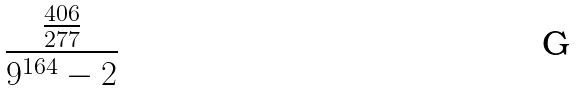<formula> <loc_0><loc_0><loc_500><loc_500>\frac { \frac { 4 0 6 } { 2 7 7 } } { 9 ^ { 1 6 4 } - 2 }</formula> 